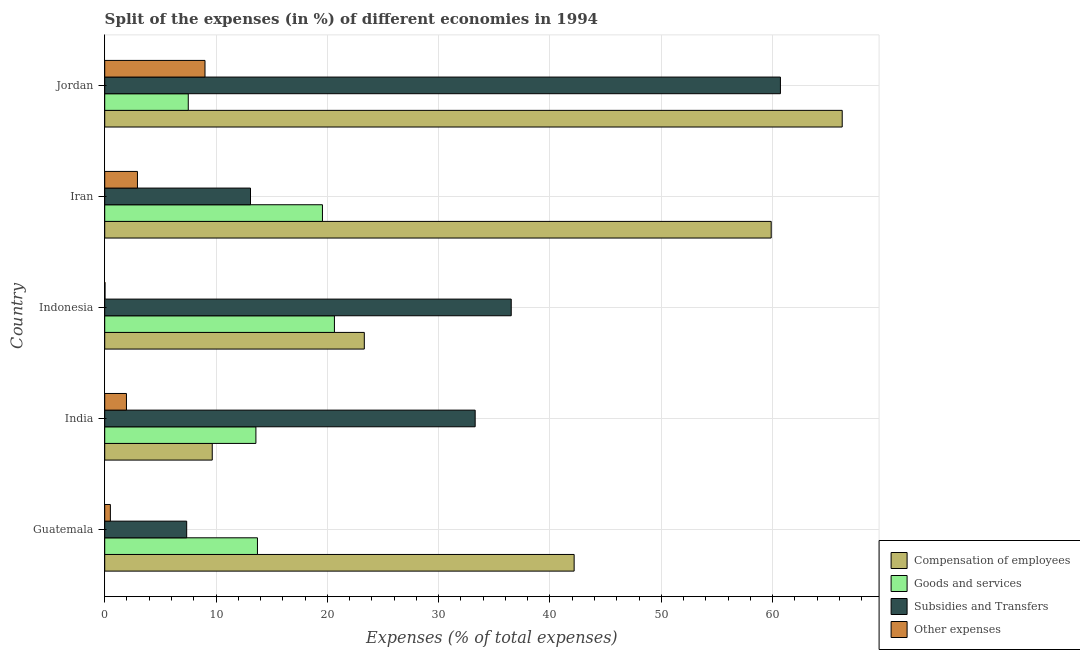Are the number of bars per tick equal to the number of legend labels?
Give a very brief answer. Yes. Are the number of bars on each tick of the Y-axis equal?
Your answer should be very brief. Yes. What is the label of the 3rd group of bars from the top?
Your response must be concise. Indonesia. In how many cases, is the number of bars for a given country not equal to the number of legend labels?
Your answer should be very brief. 0. What is the percentage of amount spent on subsidies in Jordan?
Provide a short and direct response. 60.7. Across all countries, what is the maximum percentage of amount spent on subsidies?
Ensure brevity in your answer.  60.7. Across all countries, what is the minimum percentage of amount spent on subsidies?
Ensure brevity in your answer.  7.36. In which country was the percentage of amount spent on compensation of employees maximum?
Keep it short and to the point. Jordan. In which country was the percentage of amount spent on compensation of employees minimum?
Make the answer very short. India. What is the total percentage of amount spent on subsidies in the graph?
Make the answer very short. 150.96. What is the difference between the percentage of amount spent on other expenses in Indonesia and that in Jordan?
Your answer should be very brief. -8.98. What is the difference between the percentage of amount spent on subsidies in Indonesia and the percentage of amount spent on other expenses in Jordan?
Keep it short and to the point. 27.51. What is the average percentage of amount spent on goods and services per country?
Ensure brevity in your answer.  15. What is the difference between the percentage of amount spent on subsidies and percentage of amount spent on other expenses in Guatemala?
Your answer should be compact. 6.86. In how many countries, is the percentage of amount spent on goods and services greater than 62 %?
Offer a terse response. 0. What is the ratio of the percentage of amount spent on goods and services in Indonesia to that in Jordan?
Ensure brevity in your answer.  2.75. Is the difference between the percentage of amount spent on goods and services in Guatemala and Indonesia greater than the difference between the percentage of amount spent on compensation of employees in Guatemala and Indonesia?
Ensure brevity in your answer.  No. What is the difference between the highest and the second highest percentage of amount spent on compensation of employees?
Your answer should be compact. 6.38. What is the difference between the highest and the lowest percentage of amount spent on other expenses?
Keep it short and to the point. 8.98. What does the 1st bar from the top in Iran represents?
Provide a succinct answer. Other expenses. What does the 4th bar from the bottom in Iran represents?
Provide a short and direct response. Other expenses. Is it the case that in every country, the sum of the percentage of amount spent on compensation of employees and percentage of amount spent on goods and services is greater than the percentage of amount spent on subsidies?
Offer a very short reply. No. How many bars are there?
Provide a succinct answer. 20. Are all the bars in the graph horizontal?
Provide a short and direct response. Yes. What is the difference between two consecutive major ticks on the X-axis?
Offer a very short reply. 10. Where does the legend appear in the graph?
Make the answer very short. Bottom right. What is the title of the graph?
Provide a succinct answer. Split of the expenses (in %) of different economies in 1994. Does "First 20% of population" appear as one of the legend labels in the graph?
Make the answer very short. No. What is the label or title of the X-axis?
Offer a very short reply. Expenses (% of total expenses). What is the label or title of the Y-axis?
Offer a very short reply. Country. What is the Expenses (% of total expenses) in Compensation of employees in Guatemala?
Your answer should be very brief. 42.17. What is the Expenses (% of total expenses) of Goods and services in Guatemala?
Offer a terse response. 13.72. What is the Expenses (% of total expenses) of Subsidies and Transfers in Guatemala?
Your answer should be compact. 7.36. What is the Expenses (% of total expenses) of Other expenses in Guatemala?
Provide a succinct answer. 0.51. What is the Expenses (% of total expenses) in Compensation of employees in India?
Offer a terse response. 9.66. What is the Expenses (% of total expenses) of Goods and services in India?
Offer a terse response. 13.58. What is the Expenses (% of total expenses) in Subsidies and Transfers in India?
Make the answer very short. 33.28. What is the Expenses (% of total expenses) of Other expenses in India?
Your answer should be compact. 1.95. What is the Expenses (% of total expenses) in Compensation of employees in Indonesia?
Give a very brief answer. 23.32. What is the Expenses (% of total expenses) of Goods and services in Indonesia?
Provide a succinct answer. 20.64. What is the Expenses (% of total expenses) in Subsidies and Transfers in Indonesia?
Give a very brief answer. 36.52. What is the Expenses (% of total expenses) of Other expenses in Indonesia?
Your answer should be very brief. 0.03. What is the Expenses (% of total expenses) of Compensation of employees in Iran?
Offer a terse response. 59.87. What is the Expenses (% of total expenses) in Goods and services in Iran?
Give a very brief answer. 19.56. What is the Expenses (% of total expenses) of Subsidies and Transfers in Iran?
Offer a terse response. 13.1. What is the Expenses (% of total expenses) in Other expenses in Iran?
Your answer should be compact. 2.94. What is the Expenses (% of total expenses) of Compensation of employees in Jordan?
Offer a terse response. 66.25. What is the Expenses (% of total expenses) of Goods and services in Jordan?
Provide a succinct answer. 7.51. What is the Expenses (% of total expenses) in Subsidies and Transfers in Jordan?
Your answer should be very brief. 60.7. What is the Expenses (% of total expenses) in Other expenses in Jordan?
Your answer should be compact. 9.01. Across all countries, what is the maximum Expenses (% of total expenses) in Compensation of employees?
Your response must be concise. 66.25. Across all countries, what is the maximum Expenses (% of total expenses) in Goods and services?
Make the answer very short. 20.64. Across all countries, what is the maximum Expenses (% of total expenses) in Subsidies and Transfers?
Make the answer very short. 60.7. Across all countries, what is the maximum Expenses (% of total expenses) in Other expenses?
Give a very brief answer. 9.01. Across all countries, what is the minimum Expenses (% of total expenses) in Compensation of employees?
Offer a very short reply. 9.66. Across all countries, what is the minimum Expenses (% of total expenses) in Goods and services?
Your answer should be compact. 7.51. Across all countries, what is the minimum Expenses (% of total expenses) of Subsidies and Transfers?
Provide a short and direct response. 7.36. Across all countries, what is the minimum Expenses (% of total expenses) of Other expenses?
Make the answer very short. 0.03. What is the total Expenses (% of total expenses) in Compensation of employees in the graph?
Ensure brevity in your answer.  201.28. What is the total Expenses (% of total expenses) of Goods and services in the graph?
Offer a terse response. 75.01. What is the total Expenses (% of total expenses) of Subsidies and Transfers in the graph?
Provide a short and direct response. 150.96. What is the total Expenses (% of total expenses) in Other expenses in the graph?
Your answer should be compact. 14.44. What is the difference between the Expenses (% of total expenses) in Compensation of employees in Guatemala and that in India?
Give a very brief answer. 32.51. What is the difference between the Expenses (% of total expenses) in Goods and services in Guatemala and that in India?
Offer a terse response. 0.14. What is the difference between the Expenses (% of total expenses) of Subsidies and Transfers in Guatemala and that in India?
Your response must be concise. -25.92. What is the difference between the Expenses (% of total expenses) of Other expenses in Guatemala and that in India?
Ensure brevity in your answer.  -1.44. What is the difference between the Expenses (% of total expenses) of Compensation of employees in Guatemala and that in Indonesia?
Your response must be concise. 18.85. What is the difference between the Expenses (% of total expenses) in Goods and services in Guatemala and that in Indonesia?
Give a very brief answer. -6.91. What is the difference between the Expenses (% of total expenses) of Subsidies and Transfers in Guatemala and that in Indonesia?
Your response must be concise. -29.16. What is the difference between the Expenses (% of total expenses) in Other expenses in Guatemala and that in Indonesia?
Offer a very short reply. 0.48. What is the difference between the Expenses (% of total expenses) in Compensation of employees in Guatemala and that in Iran?
Keep it short and to the point. -17.7. What is the difference between the Expenses (% of total expenses) in Goods and services in Guatemala and that in Iran?
Offer a terse response. -5.84. What is the difference between the Expenses (% of total expenses) of Subsidies and Transfers in Guatemala and that in Iran?
Make the answer very short. -5.73. What is the difference between the Expenses (% of total expenses) in Other expenses in Guatemala and that in Iran?
Your answer should be compact. -2.43. What is the difference between the Expenses (% of total expenses) of Compensation of employees in Guatemala and that in Jordan?
Ensure brevity in your answer.  -24.08. What is the difference between the Expenses (% of total expenses) in Goods and services in Guatemala and that in Jordan?
Your answer should be compact. 6.22. What is the difference between the Expenses (% of total expenses) of Subsidies and Transfers in Guatemala and that in Jordan?
Give a very brief answer. -53.34. What is the difference between the Expenses (% of total expenses) of Other expenses in Guatemala and that in Jordan?
Ensure brevity in your answer.  -8.5. What is the difference between the Expenses (% of total expenses) in Compensation of employees in India and that in Indonesia?
Offer a terse response. -13.66. What is the difference between the Expenses (% of total expenses) in Goods and services in India and that in Indonesia?
Provide a succinct answer. -7.05. What is the difference between the Expenses (% of total expenses) of Subsidies and Transfers in India and that in Indonesia?
Your answer should be very brief. -3.24. What is the difference between the Expenses (% of total expenses) in Other expenses in India and that in Indonesia?
Keep it short and to the point. 1.93. What is the difference between the Expenses (% of total expenses) in Compensation of employees in India and that in Iran?
Ensure brevity in your answer.  -50.21. What is the difference between the Expenses (% of total expenses) of Goods and services in India and that in Iran?
Make the answer very short. -5.98. What is the difference between the Expenses (% of total expenses) of Subsidies and Transfers in India and that in Iran?
Ensure brevity in your answer.  20.18. What is the difference between the Expenses (% of total expenses) in Other expenses in India and that in Iran?
Your answer should be very brief. -0.99. What is the difference between the Expenses (% of total expenses) of Compensation of employees in India and that in Jordan?
Provide a short and direct response. -56.59. What is the difference between the Expenses (% of total expenses) in Goods and services in India and that in Jordan?
Your response must be concise. 6.08. What is the difference between the Expenses (% of total expenses) in Subsidies and Transfers in India and that in Jordan?
Offer a terse response. -27.42. What is the difference between the Expenses (% of total expenses) in Other expenses in India and that in Jordan?
Your answer should be very brief. -7.06. What is the difference between the Expenses (% of total expenses) in Compensation of employees in Indonesia and that in Iran?
Ensure brevity in your answer.  -36.55. What is the difference between the Expenses (% of total expenses) of Goods and services in Indonesia and that in Iran?
Provide a short and direct response. 1.08. What is the difference between the Expenses (% of total expenses) in Subsidies and Transfers in Indonesia and that in Iran?
Your answer should be very brief. 23.42. What is the difference between the Expenses (% of total expenses) in Other expenses in Indonesia and that in Iran?
Offer a terse response. -2.91. What is the difference between the Expenses (% of total expenses) of Compensation of employees in Indonesia and that in Jordan?
Your response must be concise. -42.93. What is the difference between the Expenses (% of total expenses) of Goods and services in Indonesia and that in Jordan?
Your answer should be very brief. 13.13. What is the difference between the Expenses (% of total expenses) of Subsidies and Transfers in Indonesia and that in Jordan?
Offer a terse response. -24.18. What is the difference between the Expenses (% of total expenses) of Other expenses in Indonesia and that in Jordan?
Give a very brief answer. -8.98. What is the difference between the Expenses (% of total expenses) of Compensation of employees in Iran and that in Jordan?
Keep it short and to the point. -6.38. What is the difference between the Expenses (% of total expenses) of Goods and services in Iran and that in Jordan?
Offer a terse response. 12.06. What is the difference between the Expenses (% of total expenses) in Subsidies and Transfers in Iran and that in Jordan?
Your response must be concise. -47.61. What is the difference between the Expenses (% of total expenses) in Other expenses in Iran and that in Jordan?
Your answer should be very brief. -6.07. What is the difference between the Expenses (% of total expenses) of Compensation of employees in Guatemala and the Expenses (% of total expenses) of Goods and services in India?
Ensure brevity in your answer.  28.59. What is the difference between the Expenses (% of total expenses) in Compensation of employees in Guatemala and the Expenses (% of total expenses) in Subsidies and Transfers in India?
Your answer should be very brief. 8.89. What is the difference between the Expenses (% of total expenses) in Compensation of employees in Guatemala and the Expenses (% of total expenses) in Other expenses in India?
Your response must be concise. 40.22. What is the difference between the Expenses (% of total expenses) of Goods and services in Guatemala and the Expenses (% of total expenses) of Subsidies and Transfers in India?
Offer a very short reply. -19.56. What is the difference between the Expenses (% of total expenses) of Goods and services in Guatemala and the Expenses (% of total expenses) of Other expenses in India?
Give a very brief answer. 11.77. What is the difference between the Expenses (% of total expenses) in Subsidies and Transfers in Guatemala and the Expenses (% of total expenses) in Other expenses in India?
Offer a very short reply. 5.41. What is the difference between the Expenses (% of total expenses) in Compensation of employees in Guatemala and the Expenses (% of total expenses) in Goods and services in Indonesia?
Ensure brevity in your answer.  21.54. What is the difference between the Expenses (% of total expenses) in Compensation of employees in Guatemala and the Expenses (% of total expenses) in Subsidies and Transfers in Indonesia?
Offer a very short reply. 5.65. What is the difference between the Expenses (% of total expenses) in Compensation of employees in Guatemala and the Expenses (% of total expenses) in Other expenses in Indonesia?
Your answer should be compact. 42.15. What is the difference between the Expenses (% of total expenses) in Goods and services in Guatemala and the Expenses (% of total expenses) in Subsidies and Transfers in Indonesia?
Your response must be concise. -22.8. What is the difference between the Expenses (% of total expenses) in Goods and services in Guatemala and the Expenses (% of total expenses) in Other expenses in Indonesia?
Give a very brief answer. 13.7. What is the difference between the Expenses (% of total expenses) of Subsidies and Transfers in Guatemala and the Expenses (% of total expenses) of Other expenses in Indonesia?
Offer a very short reply. 7.34. What is the difference between the Expenses (% of total expenses) in Compensation of employees in Guatemala and the Expenses (% of total expenses) in Goods and services in Iran?
Offer a terse response. 22.61. What is the difference between the Expenses (% of total expenses) in Compensation of employees in Guatemala and the Expenses (% of total expenses) in Subsidies and Transfers in Iran?
Ensure brevity in your answer.  29.08. What is the difference between the Expenses (% of total expenses) of Compensation of employees in Guatemala and the Expenses (% of total expenses) of Other expenses in Iran?
Provide a short and direct response. 39.23. What is the difference between the Expenses (% of total expenses) in Goods and services in Guatemala and the Expenses (% of total expenses) in Subsidies and Transfers in Iran?
Keep it short and to the point. 0.63. What is the difference between the Expenses (% of total expenses) of Goods and services in Guatemala and the Expenses (% of total expenses) of Other expenses in Iran?
Make the answer very short. 10.78. What is the difference between the Expenses (% of total expenses) in Subsidies and Transfers in Guatemala and the Expenses (% of total expenses) in Other expenses in Iran?
Your answer should be compact. 4.42. What is the difference between the Expenses (% of total expenses) in Compensation of employees in Guatemala and the Expenses (% of total expenses) in Goods and services in Jordan?
Offer a terse response. 34.67. What is the difference between the Expenses (% of total expenses) in Compensation of employees in Guatemala and the Expenses (% of total expenses) in Subsidies and Transfers in Jordan?
Make the answer very short. -18.53. What is the difference between the Expenses (% of total expenses) in Compensation of employees in Guatemala and the Expenses (% of total expenses) in Other expenses in Jordan?
Offer a terse response. 33.16. What is the difference between the Expenses (% of total expenses) in Goods and services in Guatemala and the Expenses (% of total expenses) in Subsidies and Transfers in Jordan?
Your answer should be compact. -46.98. What is the difference between the Expenses (% of total expenses) in Goods and services in Guatemala and the Expenses (% of total expenses) in Other expenses in Jordan?
Your response must be concise. 4.71. What is the difference between the Expenses (% of total expenses) of Subsidies and Transfers in Guatemala and the Expenses (% of total expenses) of Other expenses in Jordan?
Your response must be concise. -1.65. What is the difference between the Expenses (% of total expenses) of Compensation of employees in India and the Expenses (% of total expenses) of Goods and services in Indonesia?
Give a very brief answer. -10.98. What is the difference between the Expenses (% of total expenses) of Compensation of employees in India and the Expenses (% of total expenses) of Subsidies and Transfers in Indonesia?
Give a very brief answer. -26.86. What is the difference between the Expenses (% of total expenses) of Compensation of employees in India and the Expenses (% of total expenses) of Other expenses in Indonesia?
Keep it short and to the point. 9.63. What is the difference between the Expenses (% of total expenses) in Goods and services in India and the Expenses (% of total expenses) in Subsidies and Transfers in Indonesia?
Offer a very short reply. -22.94. What is the difference between the Expenses (% of total expenses) in Goods and services in India and the Expenses (% of total expenses) in Other expenses in Indonesia?
Make the answer very short. 13.56. What is the difference between the Expenses (% of total expenses) of Subsidies and Transfers in India and the Expenses (% of total expenses) of Other expenses in Indonesia?
Your answer should be very brief. 33.25. What is the difference between the Expenses (% of total expenses) of Compensation of employees in India and the Expenses (% of total expenses) of Goods and services in Iran?
Provide a short and direct response. -9.9. What is the difference between the Expenses (% of total expenses) of Compensation of employees in India and the Expenses (% of total expenses) of Subsidies and Transfers in Iran?
Offer a very short reply. -3.44. What is the difference between the Expenses (% of total expenses) in Compensation of employees in India and the Expenses (% of total expenses) in Other expenses in Iran?
Your answer should be compact. 6.72. What is the difference between the Expenses (% of total expenses) in Goods and services in India and the Expenses (% of total expenses) in Subsidies and Transfers in Iran?
Ensure brevity in your answer.  0.49. What is the difference between the Expenses (% of total expenses) of Goods and services in India and the Expenses (% of total expenses) of Other expenses in Iran?
Provide a succinct answer. 10.64. What is the difference between the Expenses (% of total expenses) in Subsidies and Transfers in India and the Expenses (% of total expenses) in Other expenses in Iran?
Keep it short and to the point. 30.34. What is the difference between the Expenses (% of total expenses) in Compensation of employees in India and the Expenses (% of total expenses) in Goods and services in Jordan?
Offer a terse response. 2.16. What is the difference between the Expenses (% of total expenses) in Compensation of employees in India and the Expenses (% of total expenses) in Subsidies and Transfers in Jordan?
Give a very brief answer. -51.04. What is the difference between the Expenses (% of total expenses) in Compensation of employees in India and the Expenses (% of total expenses) in Other expenses in Jordan?
Keep it short and to the point. 0.65. What is the difference between the Expenses (% of total expenses) in Goods and services in India and the Expenses (% of total expenses) in Subsidies and Transfers in Jordan?
Provide a succinct answer. -47.12. What is the difference between the Expenses (% of total expenses) of Goods and services in India and the Expenses (% of total expenses) of Other expenses in Jordan?
Your answer should be very brief. 4.57. What is the difference between the Expenses (% of total expenses) in Subsidies and Transfers in India and the Expenses (% of total expenses) in Other expenses in Jordan?
Make the answer very short. 24.27. What is the difference between the Expenses (% of total expenses) in Compensation of employees in Indonesia and the Expenses (% of total expenses) in Goods and services in Iran?
Offer a very short reply. 3.76. What is the difference between the Expenses (% of total expenses) in Compensation of employees in Indonesia and the Expenses (% of total expenses) in Subsidies and Transfers in Iran?
Provide a short and direct response. 10.22. What is the difference between the Expenses (% of total expenses) in Compensation of employees in Indonesia and the Expenses (% of total expenses) in Other expenses in Iran?
Your answer should be compact. 20.38. What is the difference between the Expenses (% of total expenses) of Goods and services in Indonesia and the Expenses (% of total expenses) of Subsidies and Transfers in Iran?
Offer a terse response. 7.54. What is the difference between the Expenses (% of total expenses) of Goods and services in Indonesia and the Expenses (% of total expenses) of Other expenses in Iran?
Provide a short and direct response. 17.7. What is the difference between the Expenses (% of total expenses) of Subsidies and Transfers in Indonesia and the Expenses (% of total expenses) of Other expenses in Iran?
Provide a succinct answer. 33.58. What is the difference between the Expenses (% of total expenses) in Compensation of employees in Indonesia and the Expenses (% of total expenses) in Goods and services in Jordan?
Give a very brief answer. 15.82. What is the difference between the Expenses (% of total expenses) of Compensation of employees in Indonesia and the Expenses (% of total expenses) of Subsidies and Transfers in Jordan?
Provide a succinct answer. -37.38. What is the difference between the Expenses (% of total expenses) in Compensation of employees in Indonesia and the Expenses (% of total expenses) in Other expenses in Jordan?
Ensure brevity in your answer.  14.31. What is the difference between the Expenses (% of total expenses) of Goods and services in Indonesia and the Expenses (% of total expenses) of Subsidies and Transfers in Jordan?
Your answer should be very brief. -40.07. What is the difference between the Expenses (% of total expenses) of Goods and services in Indonesia and the Expenses (% of total expenses) of Other expenses in Jordan?
Offer a very short reply. 11.63. What is the difference between the Expenses (% of total expenses) of Subsidies and Transfers in Indonesia and the Expenses (% of total expenses) of Other expenses in Jordan?
Give a very brief answer. 27.51. What is the difference between the Expenses (% of total expenses) of Compensation of employees in Iran and the Expenses (% of total expenses) of Goods and services in Jordan?
Ensure brevity in your answer.  52.37. What is the difference between the Expenses (% of total expenses) of Compensation of employees in Iran and the Expenses (% of total expenses) of Subsidies and Transfers in Jordan?
Give a very brief answer. -0.83. What is the difference between the Expenses (% of total expenses) of Compensation of employees in Iran and the Expenses (% of total expenses) of Other expenses in Jordan?
Provide a succinct answer. 50.87. What is the difference between the Expenses (% of total expenses) of Goods and services in Iran and the Expenses (% of total expenses) of Subsidies and Transfers in Jordan?
Your answer should be compact. -41.14. What is the difference between the Expenses (% of total expenses) of Goods and services in Iran and the Expenses (% of total expenses) of Other expenses in Jordan?
Provide a succinct answer. 10.55. What is the difference between the Expenses (% of total expenses) of Subsidies and Transfers in Iran and the Expenses (% of total expenses) of Other expenses in Jordan?
Your answer should be very brief. 4.09. What is the average Expenses (% of total expenses) of Compensation of employees per country?
Make the answer very short. 40.26. What is the average Expenses (% of total expenses) in Goods and services per country?
Make the answer very short. 15. What is the average Expenses (% of total expenses) of Subsidies and Transfers per country?
Offer a terse response. 30.19. What is the average Expenses (% of total expenses) of Other expenses per country?
Your answer should be very brief. 2.89. What is the difference between the Expenses (% of total expenses) in Compensation of employees and Expenses (% of total expenses) in Goods and services in Guatemala?
Your answer should be compact. 28.45. What is the difference between the Expenses (% of total expenses) in Compensation of employees and Expenses (% of total expenses) in Subsidies and Transfers in Guatemala?
Your response must be concise. 34.81. What is the difference between the Expenses (% of total expenses) in Compensation of employees and Expenses (% of total expenses) in Other expenses in Guatemala?
Make the answer very short. 41.66. What is the difference between the Expenses (% of total expenses) of Goods and services and Expenses (% of total expenses) of Subsidies and Transfers in Guatemala?
Provide a succinct answer. 6.36. What is the difference between the Expenses (% of total expenses) of Goods and services and Expenses (% of total expenses) of Other expenses in Guatemala?
Make the answer very short. 13.21. What is the difference between the Expenses (% of total expenses) in Subsidies and Transfers and Expenses (% of total expenses) in Other expenses in Guatemala?
Offer a terse response. 6.86. What is the difference between the Expenses (% of total expenses) of Compensation of employees and Expenses (% of total expenses) of Goods and services in India?
Keep it short and to the point. -3.92. What is the difference between the Expenses (% of total expenses) of Compensation of employees and Expenses (% of total expenses) of Subsidies and Transfers in India?
Make the answer very short. -23.62. What is the difference between the Expenses (% of total expenses) in Compensation of employees and Expenses (% of total expenses) in Other expenses in India?
Your response must be concise. 7.71. What is the difference between the Expenses (% of total expenses) of Goods and services and Expenses (% of total expenses) of Subsidies and Transfers in India?
Keep it short and to the point. -19.7. What is the difference between the Expenses (% of total expenses) in Goods and services and Expenses (% of total expenses) in Other expenses in India?
Offer a terse response. 11.63. What is the difference between the Expenses (% of total expenses) in Subsidies and Transfers and Expenses (% of total expenses) in Other expenses in India?
Make the answer very short. 31.33. What is the difference between the Expenses (% of total expenses) in Compensation of employees and Expenses (% of total expenses) in Goods and services in Indonesia?
Ensure brevity in your answer.  2.68. What is the difference between the Expenses (% of total expenses) in Compensation of employees and Expenses (% of total expenses) in Subsidies and Transfers in Indonesia?
Keep it short and to the point. -13.2. What is the difference between the Expenses (% of total expenses) in Compensation of employees and Expenses (% of total expenses) in Other expenses in Indonesia?
Keep it short and to the point. 23.29. What is the difference between the Expenses (% of total expenses) of Goods and services and Expenses (% of total expenses) of Subsidies and Transfers in Indonesia?
Ensure brevity in your answer.  -15.88. What is the difference between the Expenses (% of total expenses) of Goods and services and Expenses (% of total expenses) of Other expenses in Indonesia?
Your answer should be compact. 20.61. What is the difference between the Expenses (% of total expenses) of Subsidies and Transfers and Expenses (% of total expenses) of Other expenses in Indonesia?
Offer a very short reply. 36.49. What is the difference between the Expenses (% of total expenses) of Compensation of employees and Expenses (% of total expenses) of Goods and services in Iran?
Keep it short and to the point. 40.31. What is the difference between the Expenses (% of total expenses) in Compensation of employees and Expenses (% of total expenses) in Subsidies and Transfers in Iran?
Ensure brevity in your answer.  46.78. What is the difference between the Expenses (% of total expenses) in Compensation of employees and Expenses (% of total expenses) in Other expenses in Iran?
Keep it short and to the point. 56.93. What is the difference between the Expenses (% of total expenses) in Goods and services and Expenses (% of total expenses) in Subsidies and Transfers in Iran?
Provide a succinct answer. 6.46. What is the difference between the Expenses (% of total expenses) of Goods and services and Expenses (% of total expenses) of Other expenses in Iran?
Offer a terse response. 16.62. What is the difference between the Expenses (% of total expenses) in Subsidies and Transfers and Expenses (% of total expenses) in Other expenses in Iran?
Keep it short and to the point. 10.16. What is the difference between the Expenses (% of total expenses) of Compensation of employees and Expenses (% of total expenses) of Goods and services in Jordan?
Your answer should be compact. 58.75. What is the difference between the Expenses (% of total expenses) in Compensation of employees and Expenses (% of total expenses) in Subsidies and Transfers in Jordan?
Your answer should be compact. 5.55. What is the difference between the Expenses (% of total expenses) of Compensation of employees and Expenses (% of total expenses) of Other expenses in Jordan?
Offer a terse response. 57.24. What is the difference between the Expenses (% of total expenses) in Goods and services and Expenses (% of total expenses) in Subsidies and Transfers in Jordan?
Provide a succinct answer. -53.2. What is the difference between the Expenses (% of total expenses) of Goods and services and Expenses (% of total expenses) of Other expenses in Jordan?
Your answer should be compact. -1.5. What is the difference between the Expenses (% of total expenses) of Subsidies and Transfers and Expenses (% of total expenses) of Other expenses in Jordan?
Give a very brief answer. 51.69. What is the ratio of the Expenses (% of total expenses) in Compensation of employees in Guatemala to that in India?
Keep it short and to the point. 4.37. What is the ratio of the Expenses (% of total expenses) in Goods and services in Guatemala to that in India?
Your answer should be compact. 1.01. What is the ratio of the Expenses (% of total expenses) of Subsidies and Transfers in Guatemala to that in India?
Your response must be concise. 0.22. What is the ratio of the Expenses (% of total expenses) of Other expenses in Guatemala to that in India?
Your response must be concise. 0.26. What is the ratio of the Expenses (% of total expenses) in Compensation of employees in Guatemala to that in Indonesia?
Give a very brief answer. 1.81. What is the ratio of the Expenses (% of total expenses) of Goods and services in Guatemala to that in Indonesia?
Offer a very short reply. 0.66. What is the ratio of the Expenses (% of total expenses) in Subsidies and Transfers in Guatemala to that in Indonesia?
Your response must be concise. 0.2. What is the ratio of the Expenses (% of total expenses) in Other expenses in Guatemala to that in Indonesia?
Your response must be concise. 19.31. What is the ratio of the Expenses (% of total expenses) of Compensation of employees in Guatemala to that in Iran?
Your answer should be compact. 0.7. What is the ratio of the Expenses (% of total expenses) in Goods and services in Guatemala to that in Iran?
Provide a succinct answer. 0.7. What is the ratio of the Expenses (% of total expenses) in Subsidies and Transfers in Guatemala to that in Iran?
Offer a very short reply. 0.56. What is the ratio of the Expenses (% of total expenses) of Other expenses in Guatemala to that in Iran?
Keep it short and to the point. 0.17. What is the ratio of the Expenses (% of total expenses) of Compensation of employees in Guatemala to that in Jordan?
Ensure brevity in your answer.  0.64. What is the ratio of the Expenses (% of total expenses) of Goods and services in Guatemala to that in Jordan?
Your answer should be compact. 1.83. What is the ratio of the Expenses (% of total expenses) of Subsidies and Transfers in Guatemala to that in Jordan?
Your response must be concise. 0.12. What is the ratio of the Expenses (% of total expenses) in Other expenses in Guatemala to that in Jordan?
Offer a terse response. 0.06. What is the ratio of the Expenses (% of total expenses) of Compensation of employees in India to that in Indonesia?
Your answer should be very brief. 0.41. What is the ratio of the Expenses (% of total expenses) of Goods and services in India to that in Indonesia?
Make the answer very short. 0.66. What is the ratio of the Expenses (% of total expenses) of Subsidies and Transfers in India to that in Indonesia?
Provide a short and direct response. 0.91. What is the ratio of the Expenses (% of total expenses) in Other expenses in India to that in Indonesia?
Your response must be concise. 74.25. What is the ratio of the Expenses (% of total expenses) of Compensation of employees in India to that in Iran?
Your answer should be very brief. 0.16. What is the ratio of the Expenses (% of total expenses) of Goods and services in India to that in Iran?
Provide a short and direct response. 0.69. What is the ratio of the Expenses (% of total expenses) of Subsidies and Transfers in India to that in Iran?
Your answer should be very brief. 2.54. What is the ratio of the Expenses (% of total expenses) in Other expenses in India to that in Iran?
Keep it short and to the point. 0.66. What is the ratio of the Expenses (% of total expenses) of Compensation of employees in India to that in Jordan?
Provide a short and direct response. 0.15. What is the ratio of the Expenses (% of total expenses) of Goods and services in India to that in Jordan?
Keep it short and to the point. 1.81. What is the ratio of the Expenses (% of total expenses) of Subsidies and Transfers in India to that in Jordan?
Ensure brevity in your answer.  0.55. What is the ratio of the Expenses (% of total expenses) of Other expenses in India to that in Jordan?
Make the answer very short. 0.22. What is the ratio of the Expenses (% of total expenses) of Compensation of employees in Indonesia to that in Iran?
Your answer should be very brief. 0.39. What is the ratio of the Expenses (% of total expenses) in Goods and services in Indonesia to that in Iran?
Give a very brief answer. 1.05. What is the ratio of the Expenses (% of total expenses) of Subsidies and Transfers in Indonesia to that in Iran?
Ensure brevity in your answer.  2.79. What is the ratio of the Expenses (% of total expenses) in Other expenses in Indonesia to that in Iran?
Your answer should be very brief. 0.01. What is the ratio of the Expenses (% of total expenses) of Compensation of employees in Indonesia to that in Jordan?
Your answer should be compact. 0.35. What is the ratio of the Expenses (% of total expenses) of Goods and services in Indonesia to that in Jordan?
Offer a terse response. 2.75. What is the ratio of the Expenses (% of total expenses) of Subsidies and Transfers in Indonesia to that in Jordan?
Offer a terse response. 0.6. What is the ratio of the Expenses (% of total expenses) in Other expenses in Indonesia to that in Jordan?
Offer a very short reply. 0. What is the ratio of the Expenses (% of total expenses) in Compensation of employees in Iran to that in Jordan?
Provide a succinct answer. 0.9. What is the ratio of the Expenses (% of total expenses) of Goods and services in Iran to that in Jordan?
Keep it short and to the point. 2.61. What is the ratio of the Expenses (% of total expenses) of Subsidies and Transfers in Iran to that in Jordan?
Your answer should be compact. 0.22. What is the ratio of the Expenses (% of total expenses) in Other expenses in Iran to that in Jordan?
Make the answer very short. 0.33. What is the difference between the highest and the second highest Expenses (% of total expenses) in Compensation of employees?
Offer a terse response. 6.38. What is the difference between the highest and the second highest Expenses (% of total expenses) of Goods and services?
Your answer should be very brief. 1.08. What is the difference between the highest and the second highest Expenses (% of total expenses) in Subsidies and Transfers?
Offer a very short reply. 24.18. What is the difference between the highest and the second highest Expenses (% of total expenses) in Other expenses?
Your response must be concise. 6.07. What is the difference between the highest and the lowest Expenses (% of total expenses) of Compensation of employees?
Your answer should be compact. 56.59. What is the difference between the highest and the lowest Expenses (% of total expenses) of Goods and services?
Your response must be concise. 13.13. What is the difference between the highest and the lowest Expenses (% of total expenses) of Subsidies and Transfers?
Make the answer very short. 53.34. What is the difference between the highest and the lowest Expenses (% of total expenses) in Other expenses?
Your answer should be very brief. 8.98. 